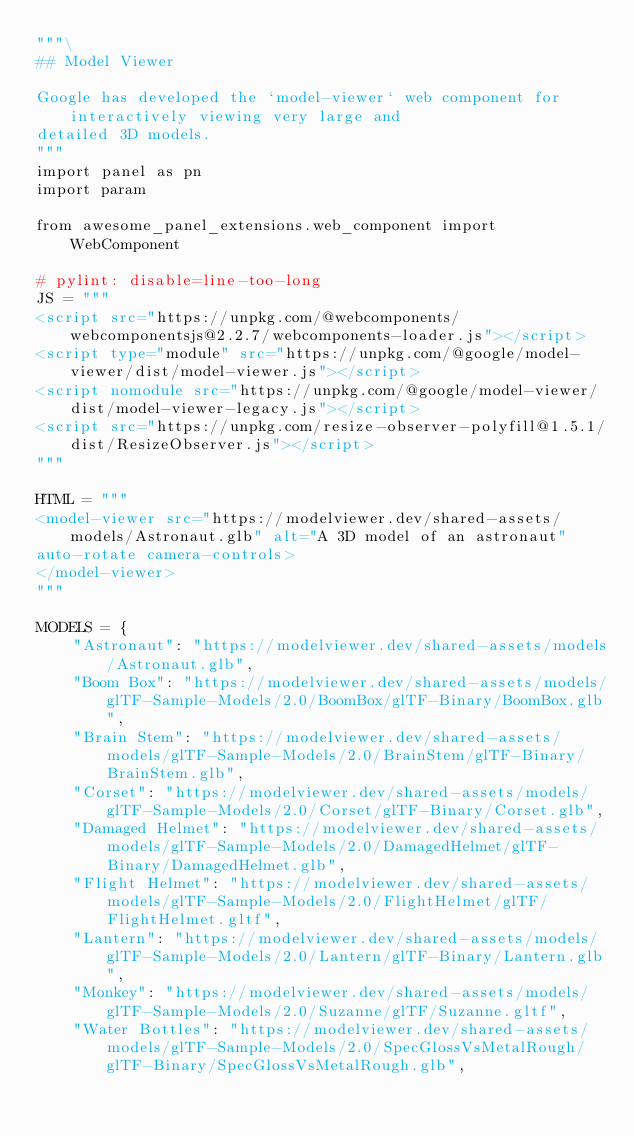<code> <loc_0><loc_0><loc_500><loc_500><_Python_>"""\
## Model Viewer

Google has developed the `model-viewer` web component for interactively viewing very large and
detailed 3D models.
"""
import panel as pn
import param

from awesome_panel_extensions.web_component import WebComponent

# pylint: disable=line-too-long
JS = """
<script src="https://unpkg.com/@webcomponents/webcomponentsjs@2.2.7/webcomponents-loader.js"></script>
<script type="module" src="https://unpkg.com/@google/model-viewer/dist/model-viewer.js"></script>
<script nomodule src="https://unpkg.com/@google/model-viewer/dist/model-viewer-legacy.js"></script>
<script src="https://unpkg.com/resize-observer-polyfill@1.5.1/dist/ResizeObserver.js"></script>
"""

HTML = """
<model-viewer src="https://modelviewer.dev/shared-assets/models/Astronaut.glb" alt="A 3D model of an astronaut"
auto-rotate camera-controls>
</model-viewer>
"""

MODELS = {
    "Astronaut": "https://modelviewer.dev/shared-assets/models/Astronaut.glb",
    "Boom Box": "https://modelviewer.dev/shared-assets/models/glTF-Sample-Models/2.0/BoomBox/glTF-Binary/BoomBox.glb",
    "Brain Stem": "https://modelviewer.dev/shared-assets/models/glTF-Sample-Models/2.0/BrainStem/glTF-Binary/BrainStem.glb",
    "Corset": "https://modelviewer.dev/shared-assets/models/glTF-Sample-Models/2.0/Corset/glTF-Binary/Corset.glb",
    "Damaged Helmet": "https://modelviewer.dev/shared-assets/models/glTF-Sample-Models/2.0/DamagedHelmet/glTF-Binary/DamagedHelmet.glb",
    "Flight Helmet": "https://modelviewer.dev/shared-assets/models/glTF-Sample-Models/2.0/FlightHelmet/glTF/FlightHelmet.gltf",
    "Lantern": "https://modelviewer.dev/shared-assets/models/glTF-Sample-Models/2.0/Lantern/glTF-Binary/Lantern.glb",
    "Monkey": "https://modelviewer.dev/shared-assets/models/glTF-Sample-Models/2.0/Suzanne/glTF/Suzanne.gltf",
    "Water Bottles": "https://modelviewer.dev/shared-assets/models/glTF-Sample-Models/2.0/SpecGlossVsMetalRough/glTF-Binary/SpecGlossVsMetalRough.glb",</code> 